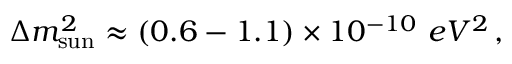<formula> <loc_0><loc_0><loc_500><loc_500>\Delta m _ { s u n } ^ { 2 } \approx ( 0 . 6 - 1 . 1 ) \times 1 0 ^ { - 1 0 } \, { e V ^ { 2 } } \, ,</formula> 